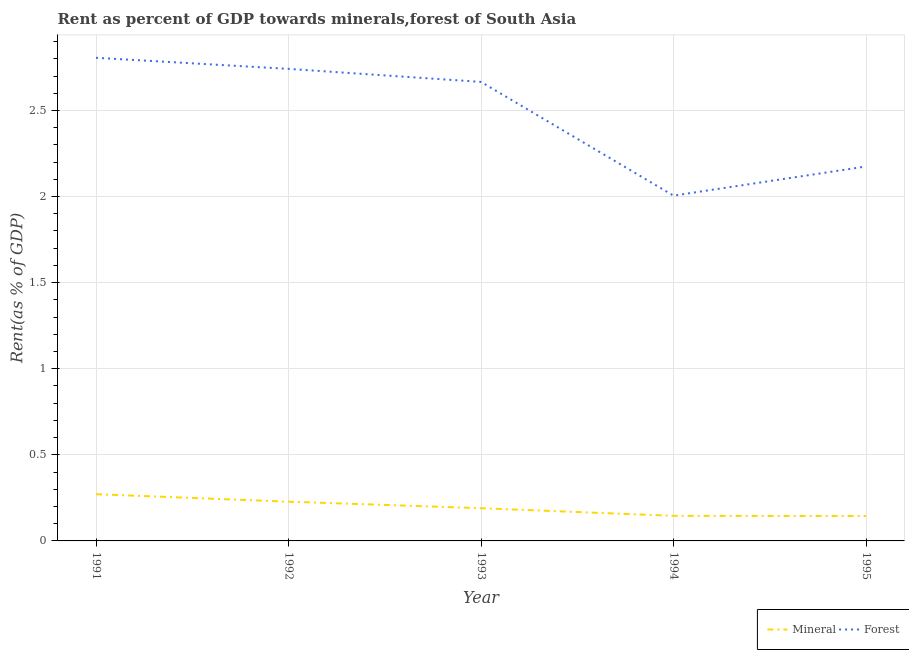How many different coloured lines are there?
Ensure brevity in your answer.  2. What is the mineral rent in 1993?
Offer a very short reply. 0.19. Across all years, what is the maximum forest rent?
Offer a terse response. 2.81. Across all years, what is the minimum mineral rent?
Give a very brief answer. 0.14. What is the total mineral rent in the graph?
Give a very brief answer. 0.98. What is the difference between the mineral rent in 1991 and that in 1994?
Keep it short and to the point. 0.13. What is the difference between the forest rent in 1992 and the mineral rent in 1995?
Your answer should be compact. 2.6. What is the average forest rent per year?
Your response must be concise. 2.48. In the year 1993, what is the difference between the mineral rent and forest rent?
Ensure brevity in your answer.  -2.48. In how many years, is the forest rent greater than 0.2 %?
Offer a terse response. 5. What is the ratio of the forest rent in 1993 to that in 1994?
Your response must be concise. 1.33. Is the forest rent in 1991 less than that in 1993?
Your answer should be compact. No. Is the difference between the forest rent in 1992 and 1995 greater than the difference between the mineral rent in 1992 and 1995?
Make the answer very short. Yes. What is the difference between the highest and the second highest mineral rent?
Offer a very short reply. 0.04. What is the difference between the highest and the lowest forest rent?
Keep it short and to the point. 0.8. In how many years, is the mineral rent greater than the average mineral rent taken over all years?
Offer a very short reply. 2. Is the sum of the mineral rent in 1993 and 1994 greater than the maximum forest rent across all years?
Offer a terse response. No. Does the forest rent monotonically increase over the years?
Your response must be concise. No. Is the forest rent strictly greater than the mineral rent over the years?
Give a very brief answer. Yes. Does the graph contain any zero values?
Keep it short and to the point. No. Does the graph contain grids?
Your answer should be compact. Yes. What is the title of the graph?
Your answer should be very brief. Rent as percent of GDP towards minerals,forest of South Asia. Does "Agricultural land" appear as one of the legend labels in the graph?
Provide a short and direct response. No. What is the label or title of the X-axis?
Provide a succinct answer. Year. What is the label or title of the Y-axis?
Your answer should be very brief. Rent(as % of GDP). What is the Rent(as % of GDP) in Mineral in 1991?
Provide a succinct answer. 0.27. What is the Rent(as % of GDP) in Forest in 1991?
Provide a succinct answer. 2.81. What is the Rent(as % of GDP) in Mineral in 1992?
Offer a very short reply. 0.23. What is the Rent(as % of GDP) of Forest in 1992?
Your answer should be very brief. 2.74. What is the Rent(as % of GDP) in Mineral in 1993?
Provide a succinct answer. 0.19. What is the Rent(as % of GDP) of Forest in 1993?
Offer a terse response. 2.67. What is the Rent(as % of GDP) of Mineral in 1994?
Provide a short and direct response. 0.15. What is the Rent(as % of GDP) of Forest in 1994?
Provide a succinct answer. 2.01. What is the Rent(as % of GDP) of Mineral in 1995?
Keep it short and to the point. 0.14. What is the Rent(as % of GDP) in Forest in 1995?
Provide a succinct answer. 2.17. Across all years, what is the maximum Rent(as % of GDP) of Mineral?
Keep it short and to the point. 0.27. Across all years, what is the maximum Rent(as % of GDP) of Forest?
Give a very brief answer. 2.81. Across all years, what is the minimum Rent(as % of GDP) of Mineral?
Provide a short and direct response. 0.14. Across all years, what is the minimum Rent(as % of GDP) of Forest?
Offer a terse response. 2.01. What is the total Rent(as % of GDP) of Mineral in the graph?
Your response must be concise. 0.98. What is the total Rent(as % of GDP) in Forest in the graph?
Ensure brevity in your answer.  12.39. What is the difference between the Rent(as % of GDP) in Mineral in 1991 and that in 1992?
Keep it short and to the point. 0.04. What is the difference between the Rent(as % of GDP) in Forest in 1991 and that in 1992?
Keep it short and to the point. 0.06. What is the difference between the Rent(as % of GDP) of Mineral in 1991 and that in 1993?
Your answer should be very brief. 0.08. What is the difference between the Rent(as % of GDP) in Forest in 1991 and that in 1993?
Provide a short and direct response. 0.14. What is the difference between the Rent(as % of GDP) in Mineral in 1991 and that in 1994?
Give a very brief answer. 0.13. What is the difference between the Rent(as % of GDP) of Forest in 1991 and that in 1994?
Offer a very short reply. 0.8. What is the difference between the Rent(as % of GDP) in Mineral in 1991 and that in 1995?
Offer a very short reply. 0.13. What is the difference between the Rent(as % of GDP) of Forest in 1991 and that in 1995?
Your response must be concise. 0.63. What is the difference between the Rent(as % of GDP) in Mineral in 1992 and that in 1993?
Provide a short and direct response. 0.04. What is the difference between the Rent(as % of GDP) in Forest in 1992 and that in 1993?
Ensure brevity in your answer.  0.08. What is the difference between the Rent(as % of GDP) of Mineral in 1992 and that in 1994?
Your answer should be compact. 0.08. What is the difference between the Rent(as % of GDP) of Forest in 1992 and that in 1994?
Keep it short and to the point. 0.74. What is the difference between the Rent(as % of GDP) in Mineral in 1992 and that in 1995?
Ensure brevity in your answer.  0.08. What is the difference between the Rent(as % of GDP) in Forest in 1992 and that in 1995?
Your answer should be very brief. 0.57. What is the difference between the Rent(as % of GDP) of Mineral in 1993 and that in 1994?
Give a very brief answer. 0.04. What is the difference between the Rent(as % of GDP) in Forest in 1993 and that in 1994?
Make the answer very short. 0.66. What is the difference between the Rent(as % of GDP) in Mineral in 1993 and that in 1995?
Give a very brief answer. 0.05. What is the difference between the Rent(as % of GDP) in Forest in 1993 and that in 1995?
Give a very brief answer. 0.49. What is the difference between the Rent(as % of GDP) in Mineral in 1994 and that in 1995?
Your answer should be very brief. 0. What is the difference between the Rent(as % of GDP) of Forest in 1994 and that in 1995?
Keep it short and to the point. -0.17. What is the difference between the Rent(as % of GDP) in Mineral in 1991 and the Rent(as % of GDP) in Forest in 1992?
Give a very brief answer. -2.47. What is the difference between the Rent(as % of GDP) of Mineral in 1991 and the Rent(as % of GDP) of Forest in 1993?
Your answer should be compact. -2.39. What is the difference between the Rent(as % of GDP) in Mineral in 1991 and the Rent(as % of GDP) in Forest in 1994?
Provide a short and direct response. -1.73. What is the difference between the Rent(as % of GDP) of Mineral in 1991 and the Rent(as % of GDP) of Forest in 1995?
Ensure brevity in your answer.  -1.9. What is the difference between the Rent(as % of GDP) in Mineral in 1992 and the Rent(as % of GDP) in Forest in 1993?
Provide a succinct answer. -2.44. What is the difference between the Rent(as % of GDP) of Mineral in 1992 and the Rent(as % of GDP) of Forest in 1994?
Your answer should be very brief. -1.78. What is the difference between the Rent(as % of GDP) of Mineral in 1992 and the Rent(as % of GDP) of Forest in 1995?
Ensure brevity in your answer.  -1.95. What is the difference between the Rent(as % of GDP) in Mineral in 1993 and the Rent(as % of GDP) in Forest in 1994?
Give a very brief answer. -1.82. What is the difference between the Rent(as % of GDP) of Mineral in 1993 and the Rent(as % of GDP) of Forest in 1995?
Ensure brevity in your answer.  -1.98. What is the difference between the Rent(as % of GDP) in Mineral in 1994 and the Rent(as % of GDP) in Forest in 1995?
Give a very brief answer. -2.03. What is the average Rent(as % of GDP) of Mineral per year?
Make the answer very short. 0.2. What is the average Rent(as % of GDP) of Forest per year?
Ensure brevity in your answer.  2.48. In the year 1991, what is the difference between the Rent(as % of GDP) in Mineral and Rent(as % of GDP) in Forest?
Ensure brevity in your answer.  -2.53. In the year 1992, what is the difference between the Rent(as % of GDP) of Mineral and Rent(as % of GDP) of Forest?
Offer a terse response. -2.51. In the year 1993, what is the difference between the Rent(as % of GDP) of Mineral and Rent(as % of GDP) of Forest?
Offer a very short reply. -2.48. In the year 1994, what is the difference between the Rent(as % of GDP) of Mineral and Rent(as % of GDP) of Forest?
Give a very brief answer. -1.86. In the year 1995, what is the difference between the Rent(as % of GDP) in Mineral and Rent(as % of GDP) in Forest?
Your response must be concise. -2.03. What is the ratio of the Rent(as % of GDP) in Mineral in 1991 to that in 1992?
Give a very brief answer. 1.19. What is the ratio of the Rent(as % of GDP) in Forest in 1991 to that in 1992?
Offer a terse response. 1.02. What is the ratio of the Rent(as % of GDP) in Mineral in 1991 to that in 1993?
Offer a very short reply. 1.43. What is the ratio of the Rent(as % of GDP) in Forest in 1991 to that in 1993?
Your answer should be compact. 1.05. What is the ratio of the Rent(as % of GDP) in Mineral in 1991 to that in 1994?
Your answer should be very brief. 1.86. What is the ratio of the Rent(as % of GDP) of Forest in 1991 to that in 1994?
Give a very brief answer. 1.4. What is the ratio of the Rent(as % of GDP) in Mineral in 1991 to that in 1995?
Your answer should be compact. 1.88. What is the ratio of the Rent(as % of GDP) in Forest in 1991 to that in 1995?
Provide a succinct answer. 1.29. What is the ratio of the Rent(as % of GDP) of Mineral in 1992 to that in 1993?
Your answer should be very brief. 1.2. What is the ratio of the Rent(as % of GDP) in Forest in 1992 to that in 1993?
Offer a terse response. 1.03. What is the ratio of the Rent(as % of GDP) in Mineral in 1992 to that in 1994?
Make the answer very short. 1.56. What is the ratio of the Rent(as % of GDP) of Forest in 1992 to that in 1994?
Provide a succinct answer. 1.37. What is the ratio of the Rent(as % of GDP) of Mineral in 1992 to that in 1995?
Your answer should be compact. 1.58. What is the ratio of the Rent(as % of GDP) of Forest in 1992 to that in 1995?
Your response must be concise. 1.26. What is the ratio of the Rent(as % of GDP) in Mineral in 1993 to that in 1994?
Your answer should be very brief. 1.3. What is the ratio of the Rent(as % of GDP) of Forest in 1993 to that in 1994?
Give a very brief answer. 1.33. What is the ratio of the Rent(as % of GDP) of Mineral in 1993 to that in 1995?
Ensure brevity in your answer.  1.31. What is the ratio of the Rent(as % of GDP) of Forest in 1993 to that in 1995?
Your answer should be very brief. 1.23. What is the ratio of the Rent(as % of GDP) in Mineral in 1994 to that in 1995?
Your response must be concise. 1.01. What is the ratio of the Rent(as % of GDP) in Forest in 1994 to that in 1995?
Keep it short and to the point. 0.92. What is the difference between the highest and the second highest Rent(as % of GDP) of Mineral?
Give a very brief answer. 0.04. What is the difference between the highest and the second highest Rent(as % of GDP) in Forest?
Offer a very short reply. 0.06. What is the difference between the highest and the lowest Rent(as % of GDP) of Mineral?
Your answer should be very brief. 0.13. What is the difference between the highest and the lowest Rent(as % of GDP) in Forest?
Your answer should be very brief. 0.8. 